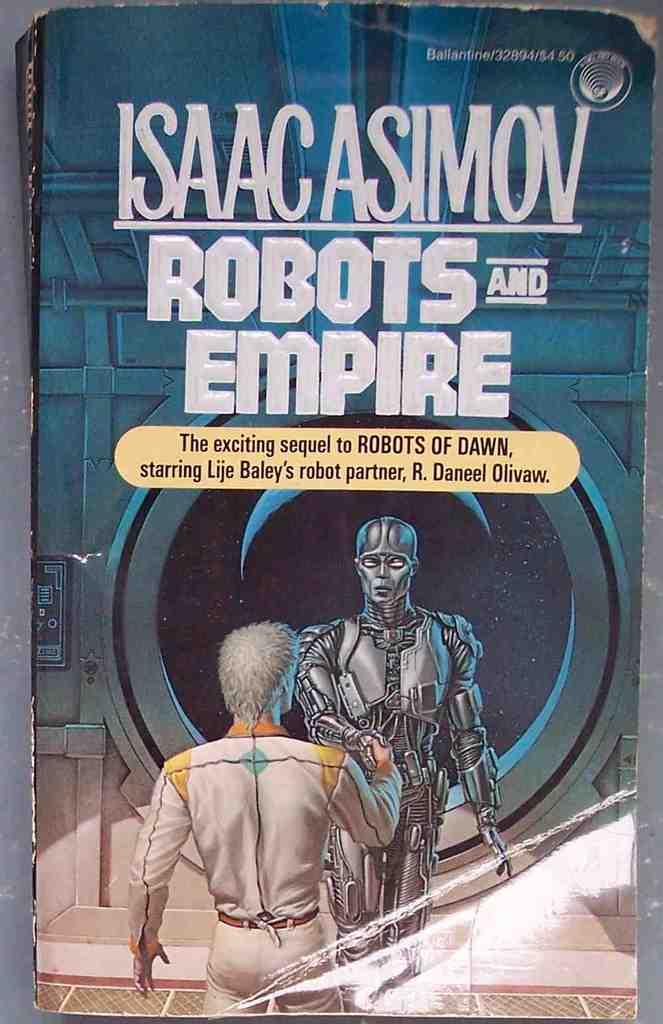Provide a one-sentence caption for the provided image. A robot meets an astronaut on the cover of an Isaac Asimov science fiction novel. 